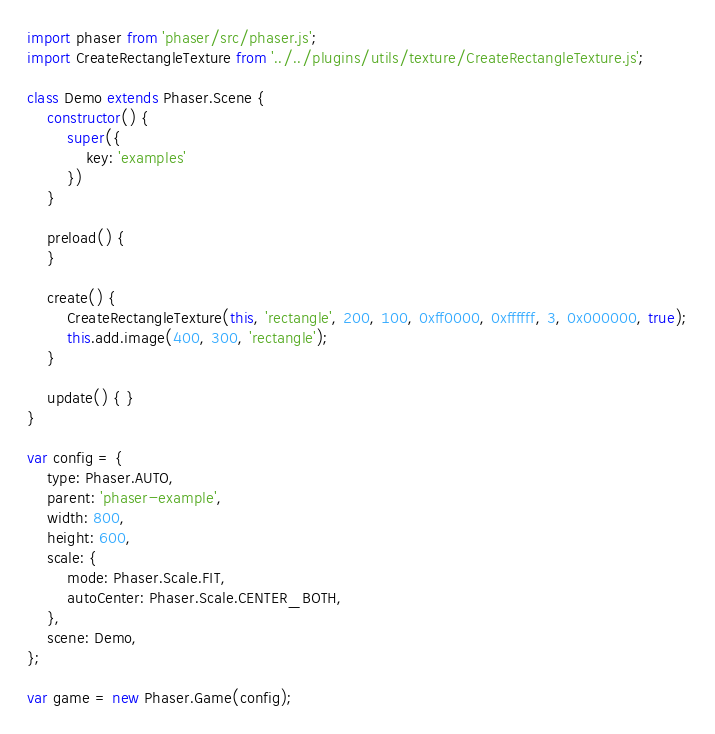Convert code to text. <code><loc_0><loc_0><loc_500><loc_500><_JavaScript_>import phaser from 'phaser/src/phaser.js';
import CreateRectangleTexture from '../../plugins/utils/texture/CreateRectangleTexture.js';

class Demo extends Phaser.Scene {
    constructor() {
        super({
            key: 'examples'
        })
    }

    preload() {
    }

    create() {
        CreateRectangleTexture(this, 'rectangle', 200, 100, 0xff0000, 0xffffff, 3, 0x000000, true);
        this.add.image(400, 300, 'rectangle');
    }

    update() { }
}

var config = {
    type: Phaser.AUTO,
    parent: 'phaser-example',
    width: 800,
    height: 600,
    scale: {
        mode: Phaser.Scale.FIT,
        autoCenter: Phaser.Scale.CENTER_BOTH,
    },
    scene: Demo,
};

var game = new Phaser.Game(config);</code> 